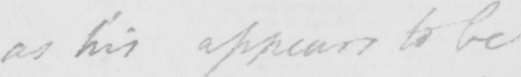Transcribe the text shown in this historical manuscript line. as his appears to be 